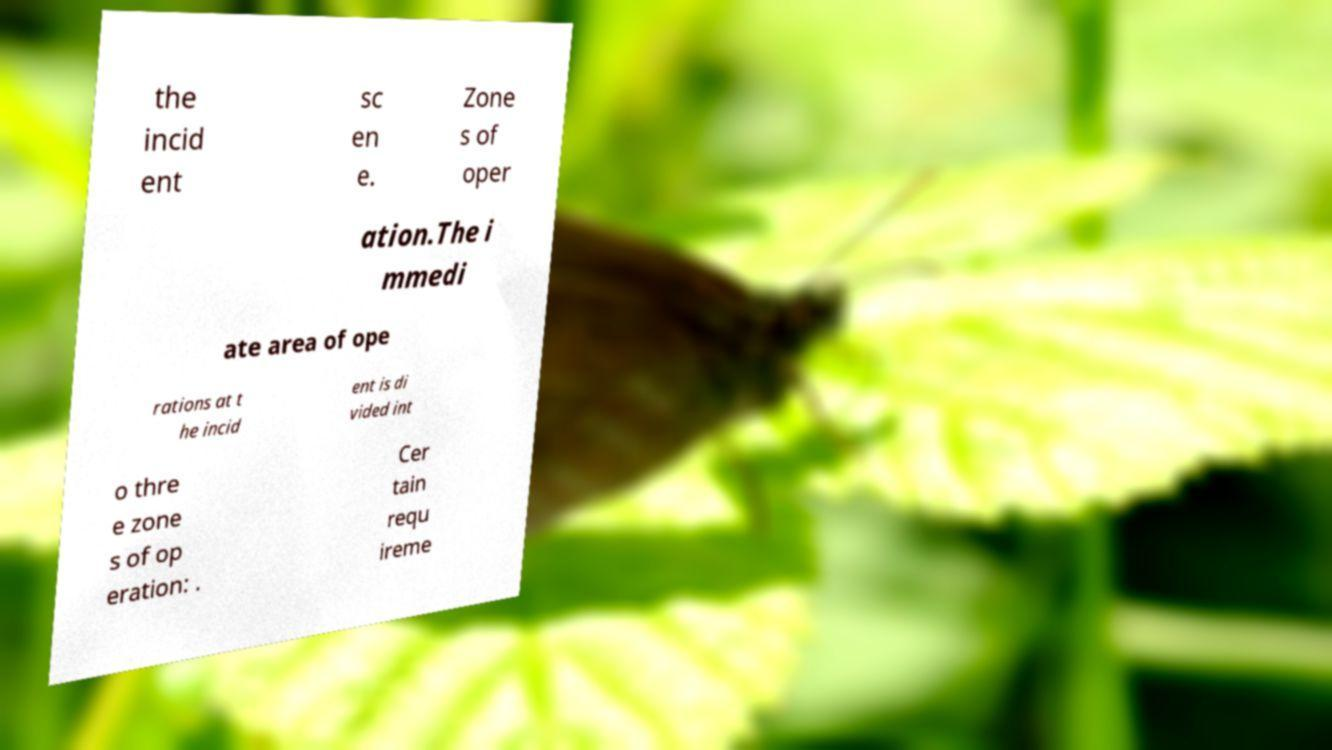Can you accurately transcribe the text from the provided image for me? the incid ent sc en e. Zone s of oper ation.The i mmedi ate area of ope rations at t he incid ent is di vided int o thre e zone s of op eration: . Cer tain requ ireme 